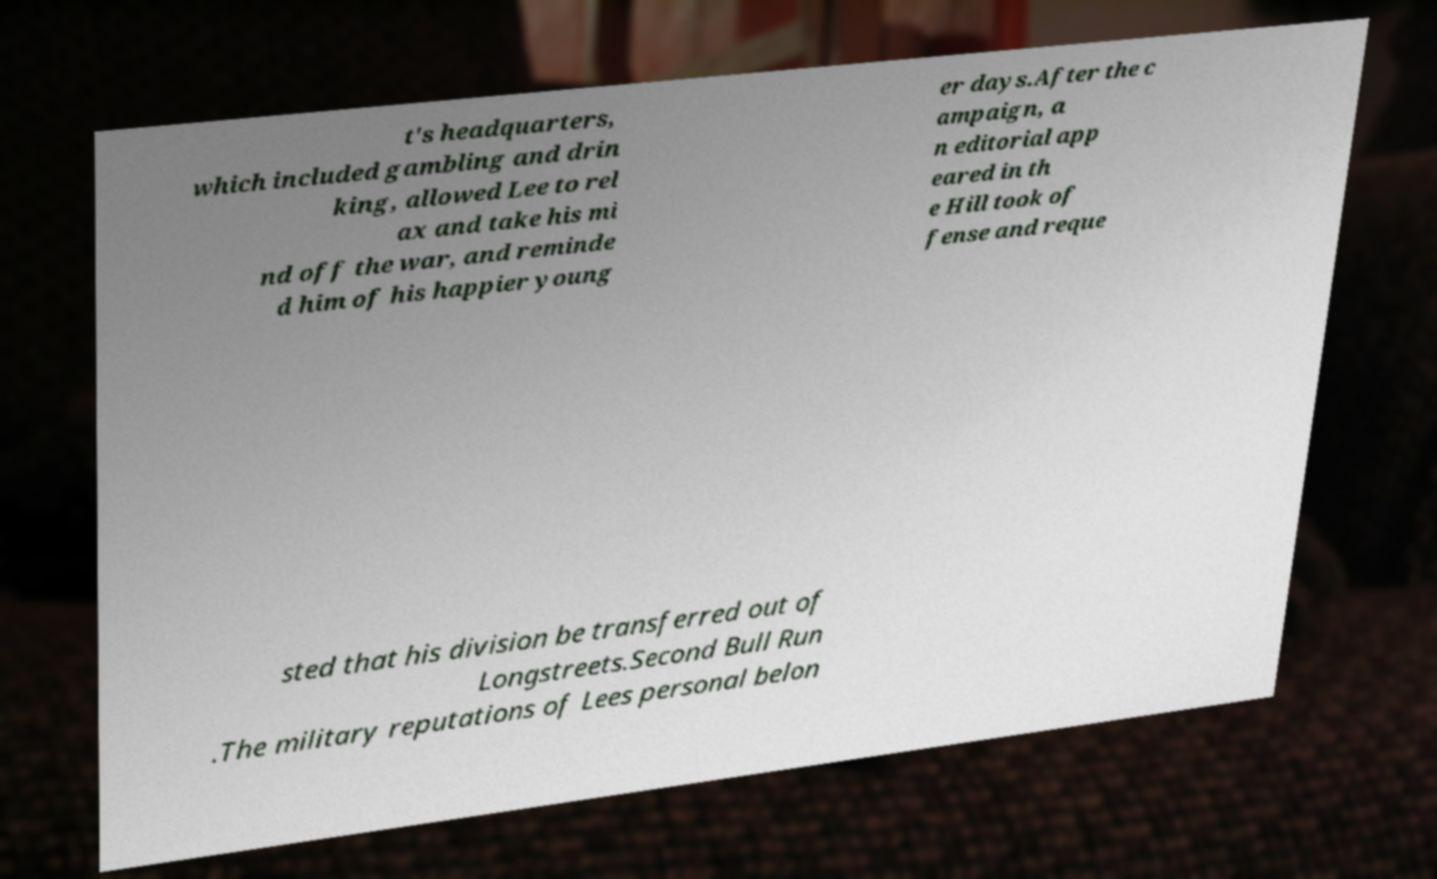Please read and relay the text visible in this image. What does it say? t's headquarters, which included gambling and drin king, allowed Lee to rel ax and take his mi nd off the war, and reminde d him of his happier young er days.After the c ampaign, a n editorial app eared in th e Hill took of fense and reque sted that his division be transferred out of Longstreets.Second Bull Run .The military reputations of Lees personal belon 